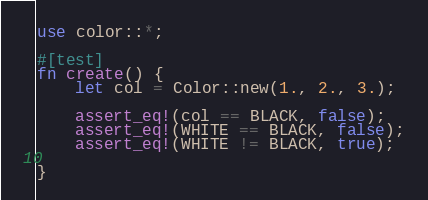<code> <loc_0><loc_0><loc_500><loc_500><_Rust_>use color::*;

#[test]
fn create() {
	let col = Color::new(1., 2., 3.);
	
	assert_eq!(col == BLACK, false);
	assert_eq!(WHITE == BLACK, false);
	assert_eq!(WHITE != BLACK, true);
	
}	</code> 